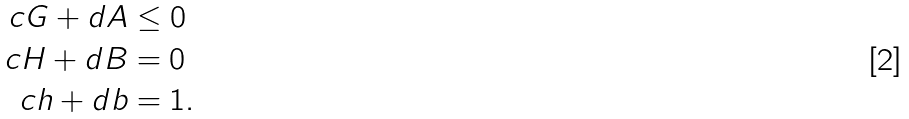<formula> <loc_0><loc_0><loc_500><loc_500>c G + d A & \leq 0 \\ c H + d B & = 0 \\ c h + d b & = 1 .</formula> 